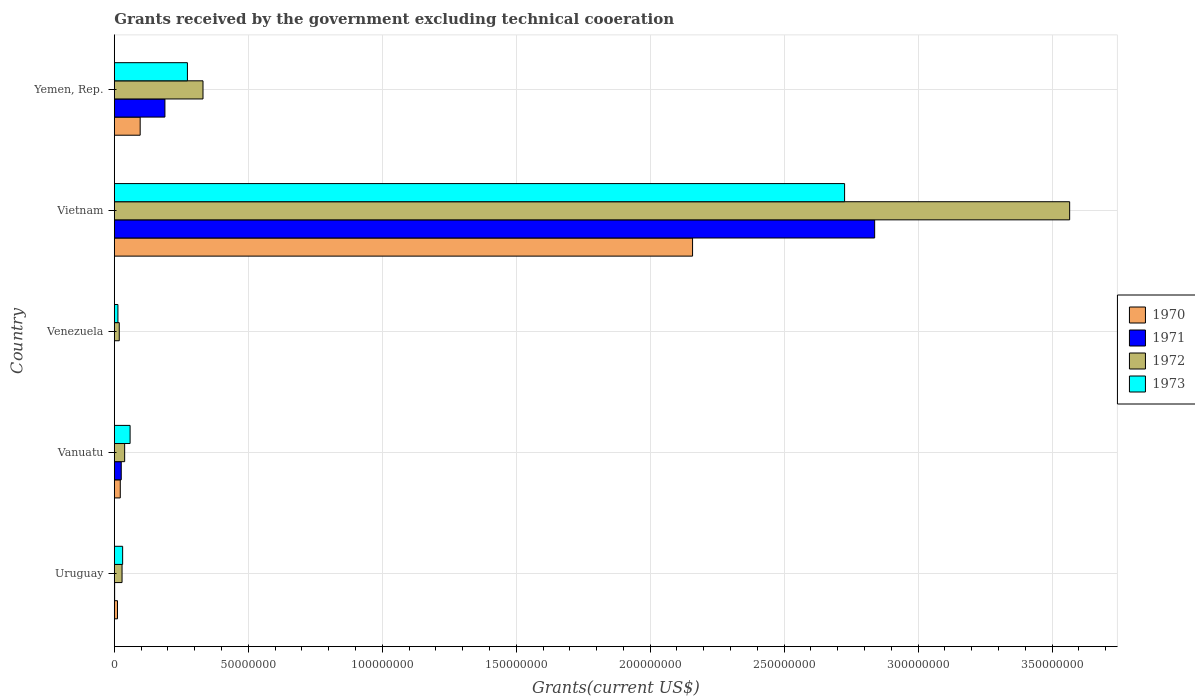Are the number of bars per tick equal to the number of legend labels?
Provide a succinct answer. Yes. Are the number of bars on each tick of the Y-axis equal?
Offer a terse response. Yes. How many bars are there on the 3rd tick from the bottom?
Offer a very short reply. 4. What is the label of the 5th group of bars from the top?
Provide a short and direct response. Uruguay. What is the total grants received by the government in 1972 in Vietnam?
Offer a very short reply. 3.57e+08. Across all countries, what is the maximum total grants received by the government in 1971?
Your answer should be very brief. 2.84e+08. Across all countries, what is the minimum total grants received by the government in 1971?
Your answer should be compact. 3.00e+04. In which country was the total grants received by the government in 1973 maximum?
Give a very brief answer. Vietnam. In which country was the total grants received by the government in 1973 minimum?
Ensure brevity in your answer.  Venezuela. What is the total total grants received by the government in 1973 in the graph?
Provide a succinct answer. 3.10e+08. What is the difference between the total grants received by the government in 1970 in Uruguay and that in Vanuatu?
Ensure brevity in your answer.  -1.04e+06. What is the difference between the total grants received by the government in 1972 in Yemen, Rep. and the total grants received by the government in 1970 in Vanuatu?
Offer a very short reply. 3.09e+07. What is the average total grants received by the government in 1973 per country?
Offer a terse response. 6.20e+07. What is the difference between the total grants received by the government in 1973 and total grants received by the government in 1972 in Vietnam?
Your answer should be compact. -8.40e+07. In how many countries, is the total grants received by the government in 1971 greater than 100000000 US$?
Keep it short and to the point. 1. What is the ratio of the total grants received by the government in 1973 in Vanuatu to that in Vietnam?
Offer a terse response. 0.02. Is the difference between the total grants received by the government in 1973 in Vietnam and Yemen, Rep. greater than the difference between the total grants received by the government in 1972 in Vietnam and Yemen, Rep.?
Your answer should be very brief. No. What is the difference between the highest and the second highest total grants received by the government in 1970?
Your answer should be very brief. 2.06e+08. What is the difference between the highest and the lowest total grants received by the government in 1970?
Offer a terse response. 2.16e+08. In how many countries, is the total grants received by the government in 1972 greater than the average total grants received by the government in 1972 taken over all countries?
Provide a succinct answer. 1. What does the 3rd bar from the top in Venezuela represents?
Make the answer very short. 1971. What does the 2nd bar from the bottom in Uruguay represents?
Keep it short and to the point. 1971. Is it the case that in every country, the sum of the total grants received by the government in 1970 and total grants received by the government in 1971 is greater than the total grants received by the government in 1973?
Provide a short and direct response. No. Are all the bars in the graph horizontal?
Your response must be concise. Yes. How many countries are there in the graph?
Keep it short and to the point. 5. What is the title of the graph?
Give a very brief answer. Grants received by the government excluding technical cooeration. Does "2008" appear as one of the legend labels in the graph?
Ensure brevity in your answer.  No. What is the label or title of the X-axis?
Offer a very short reply. Grants(current US$). What is the Grants(current US$) of 1970 in Uruguay?
Make the answer very short. 1.19e+06. What is the Grants(current US$) of 1971 in Uruguay?
Your answer should be compact. 1.20e+05. What is the Grants(current US$) in 1972 in Uruguay?
Keep it short and to the point. 2.89e+06. What is the Grants(current US$) in 1973 in Uruguay?
Your answer should be very brief. 3.11e+06. What is the Grants(current US$) in 1970 in Vanuatu?
Give a very brief answer. 2.23e+06. What is the Grants(current US$) of 1971 in Vanuatu?
Provide a succinct answer. 2.59e+06. What is the Grants(current US$) of 1972 in Vanuatu?
Provide a short and direct response. 3.86e+06. What is the Grants(current US$) of 1973 in Vanuatu?
Your answer should be compact. 5.89e+06. What is the Grants(current US$) of 1970 in Venezuela?
Ensure brevity in your answer.  10000. What is the Grants(current US$) of 1971 in Venezuela?
Your answer should be very brief. 3.00e+04. What is the Grants(current US$) of 1972 in Venezuela?
Your answer should be very brief. 1.85e+06. What is the Grants(current US$) of 1973 in Venezuela?
Your response must be concise. 1.35e+06. What is the Grants(current US$) in 1970 in Vietnam?
Make the answer very short. 2.16e+08. What is the Grants(current US$) of 1971 in Vietnam?
Provide a succinct answer. 2.84e+08. What is the Grants(current US$) of 1972 in Vietnam?
Your answer should be compact. 3.57e+08. What is the Grants(current US$) of 1973 in Vietnam?
Ensure brevity in your answer.  2.73e+08. What is the Grants(current US$) of 1970 in Yemen, Rep.?
Give a very brief answer. 9.65e+06. What is the Grants(current US$) of 1971 in Yemen, Rep.?
Make the answer very short. 1.89e+07. What is the Grants(current US$) of 1972 in Yemen, Rep.?
Ensure brevity in your answer.  3.31e+07. What is the Grants(current US$) in 1973 in Yemen, Rep.?
Give a very brief answer. 2.73e+07. Across all countries, what is the maximum Grants(current US$) in 1970?
Provide a short and direct response. 2.16e+08. Across all countries, what is the maximum Grants(current US$) of 1971?
Make the answer very short. 2.84e+08. Across all countries, what is the maximum Grants(current US$) of 1972?
Offer a very short reply. 3.57e+08. Across all countries, what is the maximum Grants(current US$) in 1973?
Ensure brevity in your answer.  2.73e+08. Across all countries, what is the minimum Grants(current US$) of 1970?
Provide a succinct answer. 10000. Across all countries, what is the minimum Grants(current US$) of 1971?
Ensure brevity in your answer.  3.00e+04. Across all countries, what is the minimum Grants(current US$) of 1972?
Your answer should be compact. 1.85e+06. Across all countries, what is the minimum Grants(current US$) in 1973?
Provide a succinct answer. 1.35e+06. What is the total Grants(current US$) of 1970 in the graph?
Give a very brief answer. 2.29e+08. What is the total Grants(current US$) of 1971 in the graph?
Give a very brief answer. 3.05e+08. What is the total Grants(current US$) of 1972 in the graph?
Ensure brevity in your answer.  3.98e+08. What is the total Grants(current US$) of 1973 in the graph?
Make the answer very short. 3.10e+08. What is the difference between the Grants(current US$) in 1970 in Uruguay and that in Vanuatu?
Offer a terse response. -1.04e+06. What is the difference between the Grants(current US$) in 1971 in Uruguay and that in Vanuatu?
Ensure brevity in your answer.  -2.47e+06. What is the difference between the Grants(current US$) of 1972 in Uruguay and that in Vanuatu?
Make the answer very short. -9.70e+05. What is the difference between the Grants(current US$) of 1973 in Uruguay and that in Vanuatu?
Your answer should be very brief. -2.78e+06. What is the difference between the Grants(current US$) in 1970 in Uruguay and that in Venezuela?
Provide a succinct answer. 1.18e+06. What is the difference between the Grants(current US$) of 1972 in Uruguay and that in Venezuela?
Offer a very short reply. 1.04e+06. What is the difference between the Grants(current US$) of 1973 in Uruguay and that in Venezuela?
Provide a succinct answer. 1.76e+06. What is the difference between the Grants(current US$) in 1970 in Uruguay and that in Vietnam?
Make the answer very short. -2.15e+08. What is the difference between the Grants(current US$) of 1971 in Uruguay and that in Vietnam?
Your response must be concise. -2.84e+08. What is the difference between the Grants(current US$) in 1972 in Uruguay and that in Vietnam?
Your response must be concise. -3.54e+08. What is the difference between the Grants(current US$) in 1973 in Uruguay and that in Vietnam?
Your answer should be very brief. -2.69e+08. What is the difference between the Grants(current US$) of 1970 in Uruguay and that in Yemen, Rep.?
Offer a very short reply. -8.46e+06. What is the difference between the Grants(current US$) in 1971 in Uruguay and that in Yemen, Rep.?
Your answer should be very brief. -1.88e+07. What is the difference between the Grants(current US$) in 1972 in Uruguay and that in Yemen, Rep.?
Your response must be concise. -3.02e+07. What is the difference between the Grants(current US$) of 1973 in Uruguay and that in Yemen, Rep.?
Your answer should be very brief. -2.42e+07. What is the difference between the Grants(current US$) of 1970 in Vanuatu and that in Venezuela?
Offer a very short reply. 2.22e+06. What is the difference between the Grants(current US$) in 1971 in Vanuatu and that in Venezuela?
Make the answer very short. 2.56e+06. What is the difference between the Grants(current US$) of 1972 in Vanuatu and that in Venezuela?
Provide a succinct answer. 2.01e+06. What is the difference between the Grants(current US$) in 1973 in Vanuatu and that in Venezuela?
Keep it short and to the point. 4.54e+06. What is the difference between the Grants(current US$) in 1970 in Vanuatu and that in Vietnam?
Your answer should be compact. -2.14e+08. What is the difference between the Grants(current US$) in 1971 in Vanuatu and that in Vietnam?
Ensure brevity in your answer.  -2.81e+08. What is the difference between the Grants(current US$) in 1972 in Vanuatu and that in Vietnam?
Your answer should be very brief. -3.53e+08. What is the difference between the Grants(current US$) in 1973 in Vanuatu and that in Vietnam?
Provide a short and direct response. -2.67e+08. What is the difference between the Grants(current US$) in 1970 in Vanuatu and that in Yemen, Rep.?
Your answer should be very brief. -7.42e+06. What is the difference between the Grants(current US$) of 1971 in Vanuatu and that in Yemen, Rep.?
Keep it short and to the point. -1.63e+07. What is the difference between the Grants(current US$) of 1972 in Vanuatu and that in Yemen, Rep.?
Your answer should be very brief. -2.92e+07. What is the difference between the Grants(current US$) of 1973 in Vanuatu and that in Yemen, Rep.?
Make the answer very short. -2.14e+07. What is the difference between the Grants(current US$) of 1970 in Venezuela and that in Vietnam?
Provide a short and direct response. -2.16e+08. What is the difference between the Grants(current US$) of 1971 in Venezuela and that in Vietnam?
Make the answer very short. -2.84e+08. What is the difference between the Grants(current US$) of 1972 in Venezuela and that in Vietnam?
Your answer should be compact. -3.55e+08. What is the difference between the Grants(current US$) in 1973 in Venezuela and that in Vietnam?
Offer a terse response. -2.71e+08. What is the difference between the Grants(current US$) in 1970 in Venezuela and that in Yemen, Rep.?
Give a very brief answer. -9.64e+06. What is the difference between the Grants(current US$) in 1971 in Venezuela and that in Yemen, Rep.?
Provide a short and direct response. -1.89e+07. What is the difference between the Grants(current US$) in 1972 in Venezuela and that in Yemen, Rep.?
Give a very brief answer. -3.12e+07. What is the difference between the Grants(current US$) of 1973 in Venezuela and that in Yemen, Rep.?
Your response must be concise. -2.59e+07. What is the difference between the Grants(current US$) of 1970 in Vietnam and that in Yemen, Rep.?
Ensure brevity in your answer.  2.06e+08. What is the difference between the Grants(current US$) in 1971 in Vietnam and that in Yemen, Rep.?
Offer a terse response. 2.65e+08. What is the difference between the Grants(current US$) of 1972 in Vietnam and that in Yemen, Rep.?
Keep it short and to the point. 3.23e+08. What is the difference between the Grants(current US$) in 1973 in Vietnam and that in Yemen, Rep.?
Give a very brief answer. 2.45e+08. What is the difference between the Grants(current US$) of 1970 in Uruguay and the Grants(current US$) of 1971 in Vanuatu?
Keep it short and to the point. -1.40e+06. What is the difference between the Grants(current US$) in 1970 in Uruguay and the Grants(current US$) in 1972 in Vanuatu?
Keep it short and to the point. -2.67e+06. What is the difference between the Grants(current US$) in 1970 in Uruguay and the Grants(current US$) in 1973 in Vanuatu?
Give a very brief answer. -4.70e+06. What is the difference between the Grants(current US$) in 1971 in Uruguay and the Grants(current US$) in 1972 in Vanuatu?
Offer a terse response. -3.74e+06. What is the difference between the Grants(current US$) in 1971 in Uruguay and the Grants(current US$) in 1973 in Vanuatu?
Your response must be concise. -5.77e+06. What is the difference between the Grants(current US$) in 1970 in Uruguay and the Grants(current US$) in 1971 in Venezuela?
Your answer should be compact. 1.16e+06. What is the difference between the Grants(current US$) of 1970 in Uruguay and the Grants(current US$) of 1972 in Venezuela?
Keep it short and to the point. -6.60e+05. What is the difference between the Grants(current US$) of 1971 in Uruguay and the Grants(current US$) of 1972 in Venezuela?
Make the answer very short. -1.73e+06. What is the difference between the Grants(current US$) in 1971 in Uruguay and the Grants(current US$) in 1973 in Venezuela?
Make the answer very short. -1.23e+06. What is the difference between the Grants(current US$) of 1972 in Uruguay and the Grants(current US$) of 1973 in Venezuela?
Keep it short and to the point. 1.54e+06. What is the difference between the Grants(current US$) in 1970 in Uruguay and the Grants(current US$) in 1971 in Vietnam?
Offer a very short reply. -2.83e+08. What is the difference between the Grants(current US$) in 1970 in Uruguay and the Grants(current US$) in 1972 in Vietnam?
Offer a terse response. -3.55e+08. What is the difference between the Grants(current US$) in 1970 in Uruguay and the Grants(current US$) in 1973 in Vietnam?
Offer a terse response. -2.71e+08. What is the difference between the Grants(current US$) of 1971 in Uruguay and the Grants(current US$) of 1972 in Vietnam?
Give a very brief answer. -3.56e+08. What is the difference between the Grants(current US$) in 1971 in Uruguay and the Grants(current US$) in 1973 in Vietnam?
Your answer should be very brief. -2.72e+08. What is the difference between the Grants(current US$) in 1972 in Uruguay and the Grants(current US$) in 1973 in Vietnam?
Your response must be concise. -2.70e+08. What is the difference between the Grants(current US$) of 1970 in Uruguay and the Grants(current US$) of 1971 in Yemen, Rep.?
Provide a succinct answer. -1.77e+07. What is the difference between the Grants(current US$) of 1970 in Uruguay and the Grants(current US$) of 1972 in Yemen, Rep.?
Offer a terse response. -3.19e+07. What is the difference between the Grants(current US$) of 1970 in Uruguay and the Grants(current US$) of 1973 in Yemen, Rep.?
Provide a succinct answer. -2.61e+07. What is the difference between the Grants(current US$) of 1971 in Uruguay and the Grants(current US$) of 1972 in Yemen, Rep.?
Offer a terse response. -3.30e+07. What is the difference between the Grants(current US$) in 1971 in Uruguay and the Grants(current US$) in 1973 in Yemen, Rep.?
Offer a terse response. -2.72e+07. What is the difference between the Grants(current US$) of 1972 in Uruguay and the Grants(current US$) of 1973 in Yemen, Rep.?
Keep it short and to the point. -2.44e+07. What is the difference between the Grants(current US$) of 1970 in Vanuatu and the Grants(current US$) of 1971 in Venezuela?
Offer a terse response. 2.20e+06. What is the difference between the Grants(current US$) in 1970 in Vanuatu and the Grants(current US$) in 1973 in Venezuela?
Make the answer very short. 8.80e+05. What is the difference between the Grants(current US$) of 1971 in Vanuatu and the Grants(current US$) of 1972 in Venezuela?
Give a very brief answer. 7.40e+05. What is the difference between the Grants(current US$) of 1971 in Vanuatu and the Grants(current US$) of 1973 in Venezuela?
Make the answer very short. 1.24e+06. What is the difference between the Grants(current US$) in 1972 in Vanuatu and the Grants(current US$) in 1973 in Venezuela?
Your answer should be compact. 2.51e+06. What is the difference between the Grants(current US$) in 1970 in Vanuatu and the Grants(current US$) in 1971 in Vietnam?
Ensure brevity in your answer.  -2.82e+08. What is the difference between the Grants(current US$) of 1970 in Vanuatu and the Grants(current US$) of 1972 in Vietnam?
Provide a short and direct response. -3.54e+08. What is the difference between the Grants(current US$) of 1970 in Vanuatu and the Grants(current US$) of 1973 in Vietnam?
Keep it short and to the point. -2.70e+08. What is the difference between the Grants(current US$) of 1971 in Vanuatu and the Grants(current US$) of 1972 in Vietnam?
Give a very brief answer. -3.54e+08. What is the difference between the Grants(current US$) in 1971 in Vanuatu and the Grants(current US$) in 1973 in Vietnam?
Provide a succinct answer. -2.70e+08. What is the difference between the Grants(current US$) of 1972 in Vanuatu and the Grants(current US$) of 1973 in Vietnam?
Your answer should be very brief. -2.69e+08. What is the difference between the Grants(current US$) of 1970 in Vanuatu and the Grants(current US$) of 1971 in Yemen, Rep.?
Offer a very short reply. -1.67e+07. What is the difference between the Grants(current US$) in 1970 in Vanuatu and the Grants(current US$) in 1972 in Yemen, Rep.?
Your response must be concise. -3.09e+07. What is the difference between the Grants(current US$) of 1970 in Vanuatu and the Grants(current US$) of 1973 in Yemen, Rep.?
Provide a short and direct response. -2.51e+07. What is the difference between the Grants(current US$) in 1971 in Vanuatu and the Grants(current US$) in 1972 in Yemen, Rep.?
Keep it short and to the point. -3.05e+07. What is the difference between the Grants(current US$) of 1971 in Vanuatu and the Grants(current US$) of 1973 in Yemen, Rep.?
Make the answer very short. -2.47e+07. What is the difference between the Grants(current US$) of 1972 in Vanuatu and the Grants(current US$) of 1973 in Yemen, Rep.?
Offer a very short reply. -2.34e+07. What is the difference between the Grants(current US$) of 1970 in Venezuela and the Grants(current US$) of 1971 in Vietnam?
Your answer should be compact. -2.84e+08. What is the difference between the Grants(current US$) in 1970 in Venezuela and the Grants(current US$) in 1972 in Vietnam?
Keep it short and to the point. -3.57e+08. What is the difference between the Grants(current US$) of 1970 in Venezuela and the Grants(current US$) of 1973 in Vietnam?
Provide a succinct answer. -2.73e+08. What is the difference between the Grants(current US$) of 1971 in Venezuela and the Grants(current US$) of 1972 in Vietnam?
Provide a short and direct response. -3.57e+08. What is the difference between the Grants(current US$) in 1971 in Venezuela and the Grants(current US$) in 1973 in Vietnam?
Offer a very short reply. -2.73e+08. What is the difference between the Grants(current US$) of 1972 in Venezuela and the Grants(current US$) of 1973 in Vietnam?
Your answer should be compact. -2.71e+08. What is the difference between the Grants(current US$) in 1970 in Venezuela and the Grants(current US$) in 1971 in Yemen, Rep.?
Offer a terse response. -1.89e+07. What is the difference between the Grants(current US$) of 1970 in Venezuela and the Grants(current US$) of 1972 in Yemen, Rep.?
Ensure brevity in your answer.  -3.31e+07. What is the difference between the Grants(current US$) of 1970 in Venezuela and the Grants(current US$) of 1973 in Yemen, Rep.?
Your response must be concise. -2.73e+07. What is the difference between the Grants(current US$) of 1971 in Venezuela and the Grants(current US$) of 1972 in Yemen, Rep.?
Provide a short and direct response. -3.31e+07. What is the difference between the Grants(current US$) of 1971 in Venezuela and the Grants(current US$) of 1973 in Yemen, Rep.?
Provide a succinct answer. -2.73e+07. What is the difference between the Grants(current US$) of 1972 in Venezuela and the Grants(current US$) of 1973 in Yemen, Rep.?
Provide a succinct answer. -2.54e+07. What is the difference between the Grants(current US$) of 1970 in Vietnam and the Grants(current US$) of 1971 in Yemen, Rep.?
Provide a short and direct response. 1.97e+08. What is the difference between the Grants(current US$) in 1970 in Vietnam and the Grants(current US$) in 1972 in Yemen, Rep.?
Give a very brief answer. 1.83e+08. What is the difference between the Grants(current US$) of 1970 in Vietnam and the Grants(current US$) of 1973 in Yemen, Rep.?
Your answer should be compact. 1.89e+08. What is the difference between the Grants(current US$) in 1971 in Vietnam and the Grants(current US$) in 1972 in Yemen, Rep.?
Make the answer very short. 2.51e+08. What is the difference between the Grants(current US$) of 1971 in Vietnam and the Grants(current US$) of 1973 in Yemen, Rep.?
Make the answer very short. 2.56e+08. What is the difference between the Grants(current US$) in 1972 in Vietnam and the Grants(current US$) in 1973 in Yemen, Rep.?
Keep it short and to the point. 3.29e+08. What is the average Grants(current US$) in 1970 per country?
Make the answer very short. 4.58e+07. What is the average Grants(current US$) of 1971 per country?
Give a very brief answer. 6.11e+07. What is the average Grants(current US$) in 1972 per country?
Offer a very short reply. 7.97e+07. What is the average Grants(current US$) of 1973 per country?
Provide a short and direct response. 6.20e+07. What is the difference between the Grants(current US$) of 1970 and Grants(current US$) of 1971 in Uruguay?
Offer a very short reply. 1.07e+06. What is the difference between the Grants(current US$) of 1970 and Grants(current US$) of 1972 in Uruguay?
Your response must be concise. -1.70e+06. What is the difference between the Grants(current US$) of 1970 and Grants(current US$) of 1973 in Uruguay?
Offer a very short reply. -1.92e+06. What is the difference between the Grants(current US$) in 1971 and Grants(current US$) in 1972 in Uruguay?
Give a very brief answer. -2.77e+06. What is the difference between the Grants(current US$) in 1971 and Grants(current US$) in 1973 in Uruguay?
Your answer should be very brief. -2.99e+06. What is the difference between the Grants(current US$) of 1972 and Grants(current US$) of 1973 in Uruguay?
Give a very brief answer. -2.20e+05. What is the difference between the Grants(current US$) of 1970 and Grants(current US$) of 1971 in Vanuatu?
Your response must be concise. -3.60e+05. What is the difference between the Grants(current US$) in 1970 and Grants(current US$) in 1972 in Vanuatu?
Provide a succinct answer. -1.63e+06. What is the difference between the Grants(current US$) in 1970 and Grants(current US$) in 1973 in Vanuatu?
Make the answer very short. -3.66e+06. What is the difference between the Grants(current US$) of 1971 and Grants(current US$) of 1972 in Vanuatu?
Your answer should be compact. -1.27e+06. What is the difference between the Grants(current US$) of 1971 and Grants(current US$) of 1973 in Vanuatu?
Offer a terse response. -3.30e+06. What is the difference between the Grants(current US$) of 1972 and Grants(current US$) of 1973 in Vanuatu?
Your answer should be very brief. -2.03e+06. What is the difference between the Grants(current US$) in 1970 and Grants(current US$) in 1972 in Venezuela?
Offer a very short reply. -1.84e+06. What is the difference between the Grants(current US$) in 1970 and Grants(current US$) in 1973 in Venezuela?
Keep it short and to the point. -1.34e+06. What is the difference between the Grants(current US$) of 1971 and Grants(current US$) of 1972 in Venezuela?
Offer a terse response. -1.82e+06. What is the difference between the Grants(current US$) of 1971 and Grants(current US$) of 1973 in Venezuela?
Make the answer very short. -1.32e+06. What is the difference between the Grants(current US$) in 1972 and Grants(current US$) in 1973 in Venezuela?
Keep it short and to the point. 5.00e+05. What is the difference between the Grants(current US$) in 1970 and Grants(current US$) in 1971 in Vietnam?
Ensure brevity in your answer.  -6.80e+07. What is the difference between the Grants(current US$) in 1970 and Grants(current US$) in 1972 in Vietnam?
Offer a very short reply. -1.41e+08. What is the difference between the Grants(current US$) in 1970 and Grants(current US$) in 1973 in Vietnam?
Your answer should be compact. -5.67e+07. What is the difference between the Grants(current US$) of 1971 and Grants(current US$) of 1972 in Vietnam?
Your answer should be very brief. -7.28e+07. What is the difference between the Grants(current US$) of 1971 and Grants(current US$) of 1973 in Vietnam?
Offer a very short reply. 1.12e+07. What is the difference between the Grants(current US$) of 1972 and Grants(current US$) of 1973 in Vietnam?
Ensure brevity in your answer.  8.40e+07. What is the difference between the Grants(current US$) of 1970 and Grants(current US$) of 1971 in Yemen, Rep.?
Make the answer very short. -9.24e+06. What is the difference between the Grants(current US$) in 1970 and Grants(current US$) in 1972 in Yemen, Rep.?
Provide a short and direct response. -2.34e+07. What is the difference between the Grants(current US$) of 1970 and Grants(current US$) of 1973 in Yemen, Rep.?
Your response must be concise. -1.76e+07. What is the difference between the Grants(current US$) in 1971 and Grants(current US$) in 1972 in Yemen, Rep.?
Ensure brevity in your answer.  -1.42e+07. What is the difference between the Grants(current US$) in 1971 and Grants(current US$) in 1973 in Yemen, Rep.?
Your answer should be very brief. -8.40e+06. What is the difference between the Grants(current US$) in 1972 and Grants(current US$) in 1973 in Yemen, Rep.?
Keep it short and to the point. 5.81e+06. What is the ratio of the Grants(current US$) in 1970 in Uruguay to that in Vanuatu?
Give a very brief answer. 0.53. What is the ratio of the Grants(current US$) of 1971 in Uruguay to that in Vanuatu?
Give a very brief answer. 0.05. What is the ratio of the Grants(current US$) of 1972 in Uruguay to that in Vanuatu?
Ensure brevity in your answer.  0.75. What is the ratio of the Grants(current US$) in 1973 in Uruguay to that in Vanuatu?
Make the answer very short. 0.53. What is the ratio of the Grants(current US$) in 1970 in Uruguay to that in Venezuela?
Provide a short and direct response. 119. What is the ratio of the Grants(current US$) of 1972 in Uruguay to that in Venezuela?
Your answer should be compact. 1.56. What is the ratio of the Grants(current US$) in 1973 in Uruguay to that in Venezuela?
Provide a succinct answer. 2.3. What is the ratio of the Grants(current US$) in 1970 in Uruguay to that in Vietnam?
Provide a succinct answer. 0.01. What is the ratio of the Grants(current US$) in 1972 in Uruguay to that in Vietnam?
Your answer should be very brief. 0.01. What is the ratio of the Grants(current US$) in 1973 in Uruguay to that in Vietnam?
Your answer should be compact. 0.01. What is the ratio of the Grants(current US$) in 1970 in Uruguay to that in Yemen, Rep.?
Ensure brevity in your answer.  0.12. What is the ratio of the Grants(current US$) in 1971 in Uruguay to that in Yemen, Rep.?
Offer a terse response. 0.01. What is the ratio of the Grants(current US$) in 1972 in Uruguay to that in Yemen, Rep.?
Ensure brevity in your answer.  0.09. What is the ratio of the Grants(current US$) in 1973 in Uruguay to that in Yemen, Rep.?
Offer a terse response. 0.11. What is the ratio of the Grants(current US$) of 1970 in Vanuatu to that in Venezuela?
Provide a succinct answer. 223. What is the ratio of the Grants(current US$) of 1971 in Vanuatu to that in Venezuela?
Your answer should be compact. 86.33. What is the ratio of the Grants(current US$) of 1972 in Vanuatu to that in Venezuela?
Make the answer very short. 2.09. What is the ratio of the Grants(current US$) in 1973 in Vanuatu to that in Venezuela?
Your answer should be very brief. 4.36. What is the ratio of the Grants(current US$) of 1970 in Vanuatu to that in Vietnam?
Provide a succinct answer. 0.01. What is the ratio of the Grants(current US$) of 1971 in Vanuatu to that in Vietnam?
Offer a terse response. 0.01. What is the ratio of the Grants(current US$) of 1972 in Vanuatu to that in Vietnam?
Your response must be concise. 0.01. What is the ratio of the Grants(current US$) of 1973 in Vanuatu to that in Vietnam?
Ensure brevity in your answer.  0.02. What is the ratio of the Grants(current US$) of 1970 in Vanuatu to that in Yemen, Rep.?
Your answer should be very brief. 0.23. What is the ratio of the Grants(current US$) of 1971 in Vanuatu to that in Yemen, Rep.?
Make the answer very short. 0.14. What is the ratio of the Grants(current US$) of 1972 in Vanuatu to that in Yemen, Rep.?
Your answer should be very brief. 0.12. What is the ratio of the Grants(current US$) in 1973 in Vanuatu to that in Yemen, Rep.?
Make the answer very short. 0.22. What is the ratio of the Grants(current US$) in 1970 in Venezuela to that in Vietnam?
Give a very brief answer. 0. What is the ratio of the Grants(current US$) in 1971 in Venezuela to that in Vietnam?
Keep it short and to the point. 0. What is the ratio of the Grants(current US$) in 1972 in Venezuela to that in Vietnam?
Make the answer very short. 0.01. What is the ratio of the Grants(current US$) in 1973 in Venezuela to that in Vietnam?
Ensure brevity in your answer.  0.01. What is the ratio of the Grants(current US$) of 1971 in Venezuela to that in Yemen, Rep.?
Your answer should be compact. 0. What is the ratio of the Grants(current US$) in 1972 in Venezuela to that in Yemen, Rep.?
Provide a succinct answer. 0.06. What is the ratio of the Grants(current US$) in 1973 in Venezuela to that in Yemen, Rep.?
Provide a short and direct response. 0.05. What is the ratio of the Grants(current US$) in 1970 in Vietnam to that in Yemen, Rep.?
Make the answer very short. 22.36. What is the ratio of the Grants(current US$) of 1971 in Vietnam to that in Yemen, Rep.?
Keep it short and to the point. 15.02. What is the ratio of the Grants(current US$) of 1972 in Vietnam to that in Yemen, Rep.?
Provide a succinct answer. 10.77. What is the ratio of the Grants(current US$) of 1973 in Vietnam to that in Yemen, Rep.?
Your answer should be very brief. 9.99. What is the difference between the highest and the second highest Grants(current US$) in 1970?
Make the answer very short. 2.06e+08. What is the difference between the highest and the second highest Grants(current US$) in 1971?
Provide a short and direct response. 2.65e+08. What is the difference between the highest and the second highest Grants(current US$) in 1972?
Offer a terse response. 3.23e+08. What is the difference between the highest and the second highest Grants(current US$) in 1973?
Provide a short and direct response. 2.45e+08. What is the difference between the highest and the lowest Grants(current US$) in 1970?
Give a very brief answer. 2.16e+08. What is the difference between the highest and the lowest Grants(current US$) in 1971?
Offer a terse response. 2.84e+08. What is the difference between the highest and the lowest Grants(current US$) of 1972?
Give a very brief answer. 3.55e+08. What is the difference between the highest and the lowest Grants(current US$) of 1973?
Offer a terse response. 2.71e+08. 